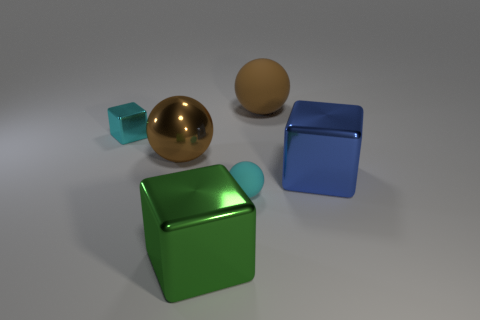Can you tell what the texture of the green object might feel like? The green object appears to have a smooth and perhaps slightly reflective metallic surface, suggesting it might feel sleek and cool to the touch. 